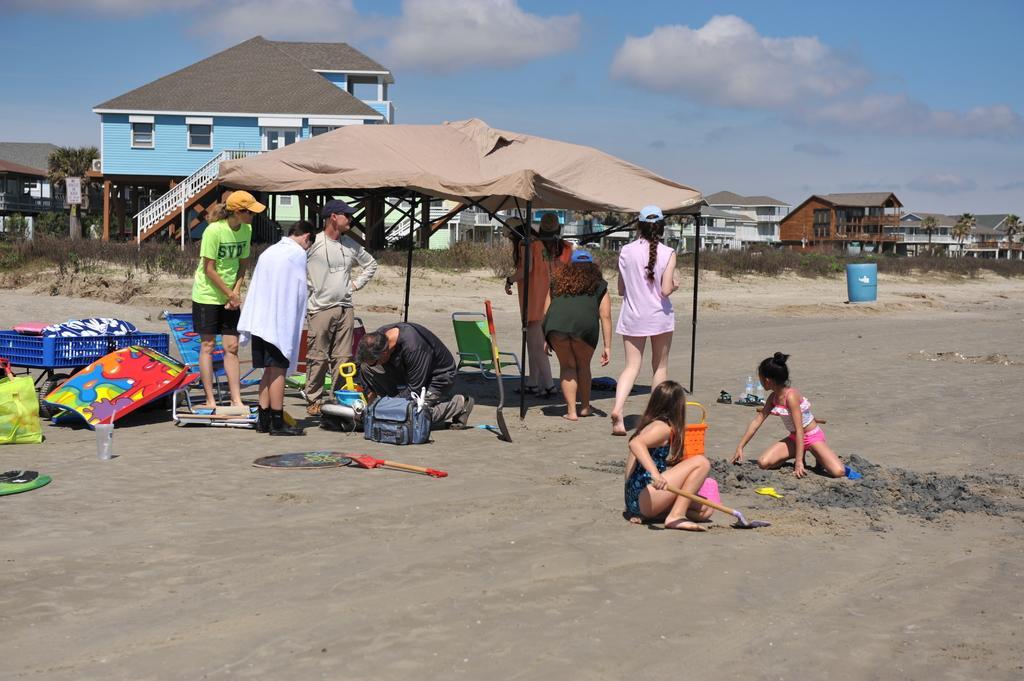How would you summarize this image in a sentence or two? In this picture I can see group of people, there are chairs and some other objects on the sand, there is a tent, there are buildings, there are plants, trees, and in the background there is the sky. 